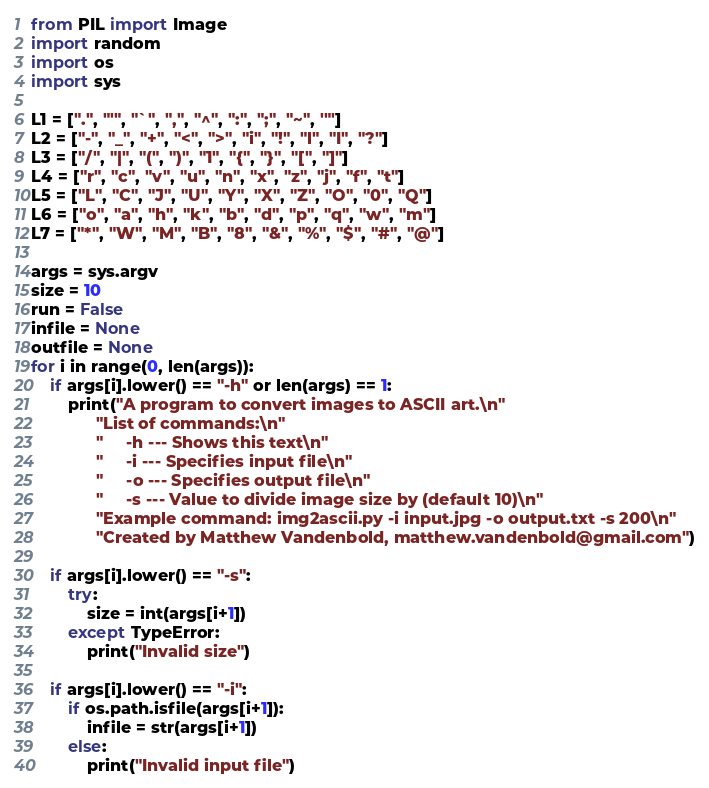<code> <loc_0><loc_0><loc_500><loc_500><_Python_>from PIL import Image
import random
import os
import sys

L1 = [".", "'", "`", ",", "^", ":", ";", "~", '"']
L2 = ["-", "_", "+", "<", ">", "i", "!", "l", "I", "?"]
L3 = ["/", "|", "(", ")", "1", "{", "}", "[", "]"]
L4 = ["r", "c", "v", "u", "n", "x", "z", "j", "f", "t"]
L5 = ["L", "C", "J", "U", "Y", "X", "Z", "O", "0", "Q"]
L6 = ["o", "a", "h", "k", "b", "d", "p", "q", "w", "m"]
L7 = ["*", "W", "M", "B", "8", "&", "%", "$", "#", "@"]

args = sys.argv
size = 10
run = False
infile = None
outfile = None
for i in range(0, len(args)):
    if args[i].lower() == "-h" or len(args) == 1:
        print("A program to convert images to ASCII art.\n"
              "List of commands:\n"
              "     -h --- Shows this text\n"
              "     -i --- Specifies input file\n"
              "     -o --- Specifies output file\n"
              "     -s --- Value to divide image size by (default 10)\n"
              "Example command: img2ascii.py -i input.jpg -o output.txt -s 200\n"
              "Created by Matthew Vandenbold, matthew.vandenbold@gmail.com")

    if args[i].lower() == "-s":
        try:
            size = int(args[i+1])
        except TypeError:
            print("Invalid size")

    if args[i].lower() == "-i":
        if os.path.isfile(args[i+1]):
            infile = str(args[i+1])
        else:
            print("Invalid input file")
</code> 